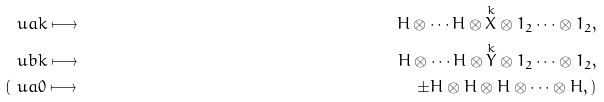Convert formula to latex. <formula><loc_0><loc_0><loc_500><loc_500>& \ u a { k } \longmapsto & H \otimes \cdots H \otimes \overset { k } { X } \otimes 1 _ { 2 } \cdots \otimes 1 _ { 2 } , \\ & \ u b { k } \longmapsto & H \otimes \cdots H \otimes \overset { k } { Y } \otimes 1 _ { 2 } \cdots \otimes 1 _ { 2 } , \\ ( & \ u a { 0 } \longmapsto & \pm H \otimes H \otimes H \otimes \cdots \otimes H , )</formula> 